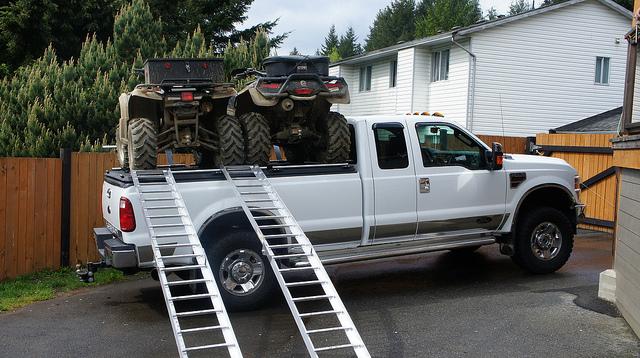What is on the roof of the car?
Keep it brief. Lights. How will the 4 wheelers get down from the truck?
Be succinct. Ramp. What do they use to unload the quads?
Give a very brief answer. Ladders. Where is this truck located?
Quick response, please. Driveway. Does it appear dangerous for a human to drive one of these vehicles off the truck?
Keep it brief. Yes. What is on the back of the truck?
Answer briefly. Atv's. Is this an old truck?
Quick response, please. No. 